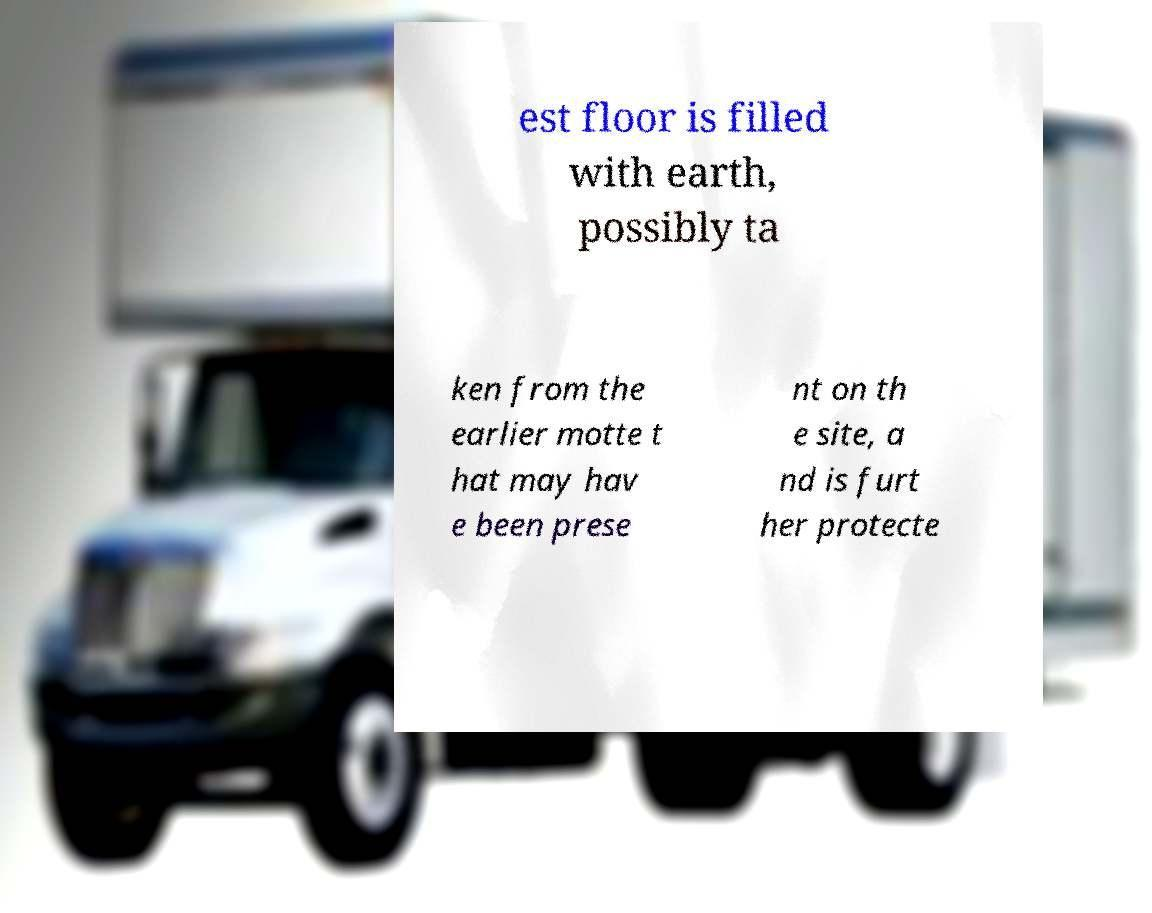Could you extract and type out the text from this image? est floor is filled with earth, possibly ta ken from the earlier motte t hat may hav e been prese nt on th e site, a nd is furt her protecte 